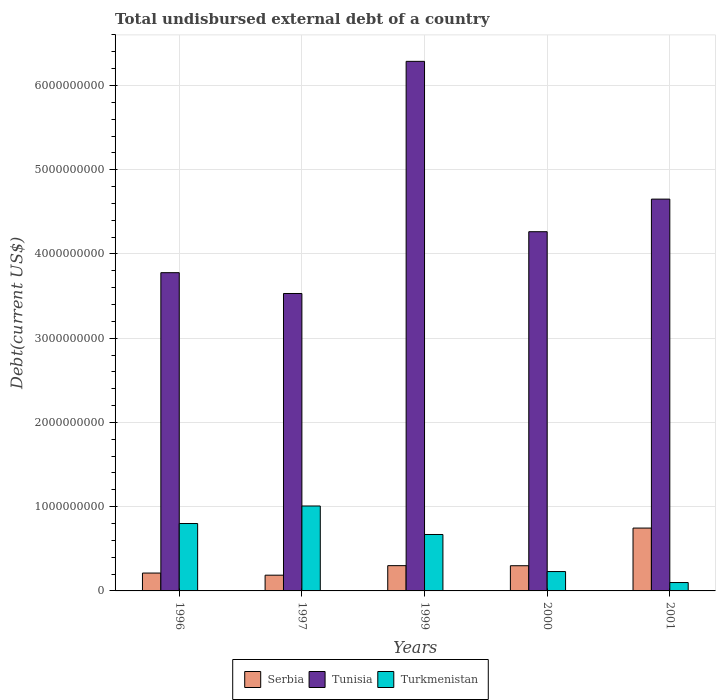How many different coloured bars are there?
Offer a terse response. 3. Are the number of bars on each tick of the X-axis equal?
Offer a terse response. Yes. What is the total undisbursed external debt in Serbia in 1999?
Offer a terse response. 3.00e+08. Across all years, what is the maximum total undisbursed external debt in Turkmenistan?
Offer a very short reply. 1.01e+09. Across all years, what is the minimum total undisbursed external debt in Tunisia?
Keep it short and to the point. 3.53e+09. What is the total total undisbursed external debt in Tunisia in the graph?
Your answer should be compact. 2.25e+1. What is the difference between the total undisbursed external debt in Turkmenistan in 1996 and that in 1999?
Your response must be concise. 1.30e+08. What is the difference between the total undisbursed external debt in Turkmenistan in 1996 and the total undisbursed external debt in Tunisia in 1999?
Make the answer very short. -5.49e+09. What is the average total undisbursed external debt in Turkmenistan per year?
Offer a terse response. 5.62e+08. In the year 1996, what is the difference between the total undisbursed external debt in Serbia and total undisbursed external debt in Turkmenistan?
Your response must be concise. -5.88e+08. What is the ratio of the total undisbursed external debt in Tunisia in 1997 to that in 2001?
Provide a succinct answer. 0.76. Is the total undisbursed external debt in Tunisia in 2000 less than that in 2001?
Offer a terse response. Yes. Is the difference between the total undisbursed external debt in Serbia in 1997 and 2000 greater than the difference between the total undisbursed external debt in Turkmenistan in 1997 and 2000?
Keep it short and to the point. No. What is the difference between the highest and the second highest total undisbursed external debt in Turkmenistan?
Provide a short and direct response. 2.08e+08. What is the difference between the highest and the lowest total undisbursed external debt in Turkmenistan?
Keep it short and to the point. 9.09e+08. In how many years, is the total undisbursed external debt in Serbia greater than the average total undisbursed external debt in Serbia taken over all years?
Your answer should be compact. 1. What does the 1st bar from the left in 1997 represents?
Your response must be concise. Serbia. What does the 2nd bar from the right in 2001 represents?
Offer a terse response. Tunisia. Is it the case that in every year, the sum of the total undisbursed external debt in Serbia and total undisbursed external debt in Turkmenistan is greater than the total undisbursed external debt in Tunisia?
Offer a very short reply. No. How many bars are there?
Ensure brevity in your answer.  15. How many years are there in the graph?
Keep it short and to the point. 5. What is the title of the graph?
Your answer should be very brief. Total undisbursed external debt of a country. Does "Angola" appear as one of the legend labels in the graph?
Your answer should be very brief. No. What is the label or title of the Y-axis?
Your answer should be very brief. Debt(current US$). What is the Debt(current US$) of Serbia in 1996?
Keep it short and to the point. 2.12e+08. What is the Debt(current US$) in Tunisia in 1996?
Offer a terse response. 3.78e+09. What is the Debt(current US$) of Turkmenistan in 1996?
Give a very brief answer. 8.00e+08. What is the Debt(current US$) in Serbia in 1997?
Make the answer very short. 1.87e+08. What is the Debt(current US$) in Tunisia in 1997?
Your response must be concise. 3.53e+09. What is the Debt(current US$) of Turkmenistan in 1997?
Your answer should be compact. 1.01e+09. What is the Debt(current US$) in Serbia in 1999?
Your answer should be compact. 3.00e+08. What is the Debt(current US$) in Tunisia in 1999?
Provide a succinct answer. 6.29e+09. What is the Debt(current US$) in Turkmenistan in 1999?
Provide a succinct answer. 6.70e+08. What is the Debt(current US$) in Serbia in 2000?
Your answer should be compact. 2.99e+08. What is the Debt(current US$) of Tunisia in 2000?
Make the answer very short. 4.26e+09. What is the Debt(current US$) in Turkmenistan in 2000?
Ensure brevity in your answer.  2.30e+08. What is the Debt(current US$) of Serbia in 2001?
Ensure brevity in your answer.  7.46e+08. What is the Debt(current US$) in Tunisia in 2001?
Your answer should be very brief. 4.65e+09. What is the Debt(current US$) of Turkmenistan in 2001?
Provide a succinct answer. 9.95e+07. Across all years, what is the maximum Debt(current US$) in Serbia?
Offer a very short reply. 7.46e+08. Across all years, what is the maximum Debt(current US$) in Tunisia?
Your answer should be very brief. 6.29e+09. Across all years, what is the maximum Debt(current US$) of Turkmenistan?
Provide a short and direct response. 1.01e+09. Across all years, what is the minimum Debt(current US$) in Serbia?
Offer a very short reply. 1.87e+08. Across all years, what is the minimum Debt(current US$) of Tunisia?
Keep it short and to the point. 3.53e+09. Across all years, what is the minimum Debt(current US$) in Turkmenistan?
Provide a succinct answer. 9.95e+07. What is the total Debt(current US$) of Serbia in the graph?
Ensure brevity in your answer.  1.74e+09. What is the total Debt(current US$) of Tunisia in the graph?
Ensure brevity in your answer.  2.25e+1. What is the total Debt(current US$) in Turkmenistan in the graph?
Make the answer very short. 2.81e+09. What is the difference between the Debt(current US$) in Serbia in 1996 and that in 1997?
Ensure brevity in your answer.  2.52e+07. What is the difference between the Debt(current US$) of Tunisia in 1996 and that in 1997?
Your answer should be very brief. 2.47e+08. What is the difference between the Debt(current US$) in Turkmenistan in 1996 and that in 1997?
Offer a terse response. -2.08e+08. What is the difference between the Debt(current US$) in Serbia in 1996 and that in 1999?
Provide a short and direct response. -8.80e+07. What is the difference between the Debt(current US$) in Tunisia in 1996 and that in 1999?
Your response must be concise. -2.51e+09. What is the difference between the Debt(current US$) in Turkmenistan in 1996 and that in 1999?
Provide a short and direct response. 1.30e+08. What is the difference between the Debt(current US$) of Serbia in 1996 and that in 2000?
Make the answer very short. -8.70e+07. What is the difference between the Debt(current US$) in Tunisia in 1996 and that in 2000?
Your answer should be very brief. -4.86e+08. What is the difference between the Debt(current US$) of Turkmenistan in 1996 and that in 2000?
Offer a very short reply. 5.70e+08. What is the difference between the Debt(current US$) of Serbia in 1996 and that in 2001?
Your response must be concise. -5.34e+08. What is the difference between the Debt(current US$) of Tunisia in 1996 and that in 2001?
Your answer should be very brief. -8.73e+08. What is the difference between the Debt(current US$) of Turkmenistan in 1996 and that in 2001?
Your answer should be very brief. 7.01e+08. What is the difference between the Debt(current US$) of Serbia in 1997 and that in 1999?
Your answer should be very brief. -1.13e+08. What is the difference between the Debt(current US$) in Tunisia in 1997 and that in 1999?
Ensure brevity in your answer.  -2.76e+09. What is the difference between the Debt(current US$) in Turkmenistan in 1997 and that in 1999?
Provide a short and direct response. 3.38e+08. What is the difference between the Debt(current US$) in Serbia in 1997 and that in 2000?
Your answer should be compact. -1.12e+08. What is the difference between the Debt(current US$) in Tunisia in 1997 and that in 2000?
Provide a succinct answer. -7.33e+08. What is the difference between the Debt(current US$) of Turkmenistan in 1997 and that in 2000?
Provide a succinct answer. 7.78e+08. What is the difference between the Debt(current US$) in Serbia in 1997 and that in 2001?
Keep it short and to the point. -5.59e+08. What is the difference between the Debt(current US$) of Tunisia in 1997 and that in 2001?
Offer a very short reply. -1.12e+09. What is the difference between the Debt(current US$) of Turkmenistan in 1997 and that in 2001?
Your answer should be very brief. 9.09e+08. What is the difference between the Debt(current US$) in Serbia in 1999 and that in 2000?
Make the answer very short. 9.52e+05. What is the difference between the Debt(current US$) in Tunisia in 1999 and that in 2000?
Make the answer very short. 2.02e+09. What is the difference between the Debt(current US$) of Turkmenistan in 1999 and that in 2000?
Offer a terse response. 4.40e+08. What is the difference between the Debt(current US$) of Serbia in 1999 and that in 2001?
Make the answer very short. -4.46e+08. What is the difference between the Debt(current US$) in Tunisia in 1999 and that in 2001?
Your answer should be compact. 1.64e+09. What is the difference between the Debt(current US$) in Turkmenistan in 1999 and that in 2001?
Give a very brief answer. 5.70e+08. What is the difference between the Debt(current US$) in Serbia in 2000 and that in 2001?
Offer a very short reply. -4.47e+08. What is the difference between the Debt(current US$) in Tunisia in 2000 and that in 2001?
Offer a very short reply. -3.87e+08. What is the difference between the Debt(current US$) in Turkmenistan in 2000 and that in 2001?
Make the answer very short. 1.30e+08. What is the difference between the Debt(current US$) of Serbia in 1996 and the Debt(current US$) of Tunisia in 1997?
Keep it short and to the point. -3.32e+09. What is the difference between the Debt(current US$) of Serbia in 1996 and the Debt(current US$) of Turkmenistan in 1997?
Provide a succinct answer. -7.96e+08. What is the difference between the Debt(current US$) in Tunisia in 1996 and the Debt(current US$) in Turkmenistan in 1997?
Your answer should be compact. 2.77e+09. What is the difference between the Debt(current US$) in Serbia in 1996 and the Debt(current US$) in Tunisia in 1999?
Your answer should be compact. -6.07e+09. What is the difference between the Debt(current US$) of Serbia in 1996 and the Debt(current US$) of Turkmenistan in 1999?
Keep it short and to the point. -4.58e+08. What is the difference between the Debt(current US$) of Tunisia in 1996 and the Debt(current US$) of Turkmenistan in 1999?
Offer a very short reply. 3.11e+09. What is the difference between the Debt(current US$) of Serbia in 1996 and the Debt(current US$) of Tunisia in 2000?
Provide a short and direct response. -4.05e+09. What is the difference between the Debt(current US$) of Serbia in 1996 and the Debt(current US$) of Turkmenistan in 2000?
Keep it short and to the point. -1.79e+07. What is the difference between the Debt(current US$) in Tunisia in 1996 and the Debt(current US$) in Turkmenistan in 2000?
Your answer should be very brief. 3.55e+09. What is the difference between the Debt(current US$) of Serbia in 1996 and the Debt(current US$) of Tunisia in 2001?
Provide a short and direct response. -4.44e+09. What is the difference between the Debt(current US$) in Serbia in 1996 and the Debt(current US$) in Turkmenistan in 2001?
Give a very brief answer. 1.13e+08. What is the difference between the Debt(current US$) in Tunisia in 1996 and the Debt(current US$) in Turkmenistan in 2001?
Make the answer very short. 3.68e+09. What is the difference between the Debt(current US$) of Serbia in 1997 and the Debt(current US$) of Tunisia in 1999?
Give a very brief answer. -6.10e+09. What is the difference between the Debt(current US$) of Serbia in 1997 and the Debt(current US$) of Turkmenistan in 1999?
Your answer should be compact. -4.83e+08. What is the difference between the Debt(current US$) in Tunisia in 1997 and the Debt(current US$) in Turkmenistan in 1999?
Ensure brevity in your answer.  2.86e+09. What is the difference between the Debt(current US$) of Serbia in 1997 and the Debt(current US$) of Tunisia in 2000?
Ensure brevity in your answer.  -4.08e+09. What is the difference between the Debt(current US$) in Serbia in 1997 and the Debt(current US$) in Turkmenistan in 2000?
Give a very brief answer. -4.31e+07. What is the difference between the Debt(current US$) in Tunisia in 1997 and the Debt(current US$) in Turkmenistan in 2000?
Offer a terse response. 3.30e+09. What is the difference between the Debt(current US$) in Serbia in 1997 and the Debt(current US$) in Tunisia in 2001?
Offer a very short reply. -4.46e+09. What is the difference between the Debt(current US$) of Serbia in 1997 and the Debt(current US$) of Turkmenistan in 2001?
Your answer should be compact. 8.73e+07. What is the difference between the Debt(current US$) of Tunisia in 1997 and the Debt(current US$) of Turkmenistan in 2001?
Ensure brevity in your answer.  3.43e+09. What is the difference between the Debt(current US$) in Serbia in 1999 and the Debt(current US$) in Tunisia in 2000?
Provide a succinct answer. -3.96e+09. What is the difference between the Debt(current US$) of Serbia in 1999 and the Debt(current US$) of Turkmenistan in 2000?
Your answer should be very brief. 7.01e+07. What is the difference between the Debt(current US$) in Tunisia in 1999 and the Debt(current US$) in Turkmenistan in 2000?
Keep it short and to the point. 6.06e+09. What is the difference between the Debt(current US$) of Serbia in 1999 and the Debt(current US$) of Tunisia in 2001?
Give a very brief answer. -4.35e+09. What is the difference between the Debt(current US$) of Serbia in 1999 and the Debt(current US$) of Turkmenistan in 2001?
Your response must be concise. 2.00e+08. What is the difference between the Debt(current US$) of Tunisia in 1999 and the Debt(current US$) of Turkmenistan in 2001?
Keep it short and to the point. 6.19e+09. What is the difference between the Debt(current US$) of Serbia in 2000 and the Debt(current US$) of Tunisia in 2001?
Ensure brevity in your answer.  -4.35e+09. What is the difference between the Debt(current US$) of Serbia in 2000 and the Debt(current US$) of Turkmenistan in 2001?
Keep it short and to the point. 2.00e+08. What is the difference between the Debt(current US$) in Tunisia in 2000 and the Debt(current US$) in Turkmenistan in 2001?
Offer a very short reply. 4.16e+09. What is the average Debt(current US$) of Serbia per year?
Give a very brief answer. 3.49e+08. What is the average Debt(current US$) in Tunisia per year?
Provide a succinct answer. 4.50e+09. What is the average Debt(current US$) of Turkmenistan per year?
Keep it short and to the point. 5.62e+08. In the year 1996, what is the difference between the Debt(current US$) in Serbia and Debt(current US$) in Tunisia?
Your answer should be compact. -3.57e+09. In the year 1996, what is the difference between the Debt(current US$) in Serbia and Debt(current US$) in Turkmenistan?
Your answer should be compact. -5.88e+08. In the year 1996, what is the difference between the Debt(current US$) in Tunisia and Debt(current US$) in Turkmenistan?
Provide a succinct answer. 2.98e+09. In the year 1997, what is the difference between the Debt(current US$) of Serbia and Debt(current US$) of Tunisia?
Keep it short and to the point. -3.34e+09. In the year 1997, what is the difference between the Debt(current US$) of Serbia and Debt(current US$) of Turkmenistan?
Offer a very short reply. -8.21e+08. In the year 1997, what is the difference between the Debt(current US$) in Tunisia and Debt(current US$) in Turkmenistan?
Your answer should be very brief. 2.52e+09. In the year 1999, what is the difference between the Debt(current US$) of Serbia and Debt(current US$) of Tunisia?
Give a very brief answer. -5.99e+09. In the year 1999, what is the difference between the Debt(current US$) of Serbia and Debt(current US$) of Turkmenistan?
Offer a terse response. -3.70e+08. In the year 1999, what is the difference between the Debt(current US$) in Tunisia and Debt(current US$) in Turkmenistan?
Your answer should be very brief. 5.62e+09. In the year 2000, what is the difference between the Debt(current US$) of Serbia and Debt(current US$) of Tunisia?
Make the answer very short. -3.97e+09. In the year 2000, what is the difference between the Debt(current US$) in Serbia and Debt(current US$) in Turkmenistan?
Make the answer very short. 6.91e+07. In the year 2000, what is the difference between the Debt(current US$) of Tunisia and Debt(current US$) of Turkmenistan?
Your response must be concise. 4.03e+09. In the year 2001, what is the difference between the Debt(current US$) of Serbia and Debt(current US$) of Tunisia?
Give a very brief answer. -3.90e+09. In the year 2001, what is the difference between the Debt(current US$) in Serbia and Debt(current US$) in Turkmenistan?
Offer a very short reply. 6.47e+08. In the year 2001, what is the difference between the Debt(current US$) of Tunisia and Debt(current US$) of Turkmenistan?
Provide a succinct answer. 4.55e+09. What is the ratio of the Debt(current US$) of Serbia in 1996 to that in 1997?
Provide a short and direct response. 1.13. What is the ratio of the Debt(current US$) in Tunisia in 1996 to that in 1997?
Provide a short and direct response. 1.07. What is the ratio of the Debt(current US$) of Turkmenistan in 1996 to that in 1997?
Ensure brevity in your answer.  0.79. What is the ratio of the Debt(current US$) in Serbia in 1996 to that in 1999?
Offer a very short reply. 0.71. What is the ratio of the Debt(current US$) in Tunisia in 1996 to that in 1999?
Provide a short and direct response. 0.6. What is the ratio of the Debt(current US$) of Turkmenistan in 1996 to that in 1999?
Keep it short and to the point. 1.19. What is the ratio of the Debt(current US$) in Serbia in 1996 to that in 2000?
Ensure brevity in your answer.  0.71. What is the ratio of the Debt(current US$) in Tunisia in 1996 to that in 2000?
Make the answer very short. 0.89. What is the ratio of the Debt(current US$) of Turkmenistan in 1996 to that in 2000?
Provide a succinct answer. 3.48. What is the ratio of the Debt(current US$) of Serbia in 1996 to that in 2001?
Offer a very short reply. 0.28. What is the ratio of the Debt(current US$) in Tunisia in 1996 to that in 2001?
Offer a terse response. 0.81. What is the ratio of the Debt(current US$) in Turkmenistan in 1996 to that in 2001?
Your response must be concise. 8.04. What is the ratio of the Debt(current US$) in Serbia in 1997 to that in 1999?
Provide a short and direct response. 0.62. What is the ratio of the Debt(current US$) in Tunisia in 1997 to that in 1999?
Offer a very short reply. 0.56. What is the ratio of the Debt(current US$) of Turkmenistan in 1997 to that in 1999?
Provide a short and direct response. 1.5. What is the ratio of the Debt(current US$) in Serbia in 1997 to that in 2000?
Your response must be concise. 0.62. What is the ratio of the Debt(current US$) of Tunisia in 1997 to that in 2000?
Provide a short and direct response. 0.83. What is the ratio of the Debt(current US$) in Turkmenistan in 1997 to that in 2000?
Keep it short and to the point. 4.39. What is the ratio of the Debt(current US$) of Serbia in 1997 to that in 2001?
Provide a succinct answer. 0.25. What is the ratio of the Debt(current US$) of Tunisia in 1997 to that in 2001?
Offer a very short reply. 0.76. What is the ratio of the Debt(current US$) of Turkmenistan in 1997 to that in 2001?
Offer a terse response. 10.13. What is the ratio of the Debt(current US$) in Tunisia in 1999 to that in 2000?
Make the answer very short. 1.47. What is the ratio of the Debt(current US$) in Turkmenistan in 1999 to that in 2000?
Give a very brief answer. 2.91. What is the ratio of the Debt(current US$) in Serbia in 1999 to that in 2001?
Make the answer very short. 0.4. What is the ratio of the Debt(current US$) in Tunisia in 1999 to that in 2001?
Provide a short and direct response. 1.35. What is the ratio of the Debt(current US$) in Turkmenistan in 1999 to that in 2001?
Keep it short and to the point. 6.73. What is the ratio of the Debt(current US$) of Serbia in 2000 to that in 2001?
Offer a terse response. 0.4. What is the ratio of the Debt(current US$) in Tunisia in 2000 to that in 2001?
Keep it short and to the point. 0.92. What is the ratio of the Debt(current US$) of Turkmenistan in 2000 to that in 2001?
Provide a succinct answer. 2.31. What is the difference between the highest and the second highest Debt(current US$) in Serbia?
Your response must be concise. 4.46e+08. What is the difference between the highest and the second highest Debt(current US$) in Tunisia?
Give a very brief answer. 1.64e+09. What is the difference between the highest and the second highest Debt(current US$) of Turkmenistan?
Your response must be concise. 2.08e+08. What is the difference between the highest and the lowest Debt(current US$) of Serbia?
Offer a very short reply. 5.59e+08. What is the difference between the highest and the lowest Debt(current US$) in Tunisia?
Your answer should be very brief. 2.76e+09. What is the difference between the highest and the lowest Debt(current US$) of Turkmenistan?
Make the answer very short. 9.09e+08. 